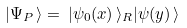<formula> <loc_0><loc_0><loc_500><loc_500>| \Psi _ { P } \, \rangle = \, | \psi _ { 0 } ( x ) \, \rangle _ { R } | \psi ( y ) \, \rangle</formula> 